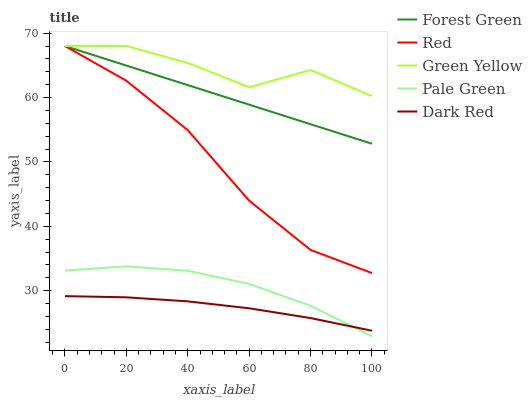Does Dark Red have the minimum area under the curve?
Answer yes or no. Yes. Does Green Yellow have the maximum area under the curve?
Answer yes or no. Yes. Does Forest Green have the minimum area under the curve?
Answer yes or no. No. Does Forest Green have the maximum area under the curve?
Answer yes or no. No. Is Forest Green the smoothest?
Answer yes or no. Yes. Is Green Yellow the roughest?
Answer yes or no. Yes. Is Green Yellow the smoothest?
Answer yes or no. No. Is Forest Green the roughest?
Answer yes or no. No. Does Forest Green have the lowest value?
Answer yes or no. No. Does Dark Red have the highest value?
Answer yes or no. No. Is Pale Green less than Red?
Answer yes or no. Yes. Is Forest Green greater than Dark Red?
Answer yes or no. Yes. Does Pale Green intersect Red?
Answer yes or no. No. 